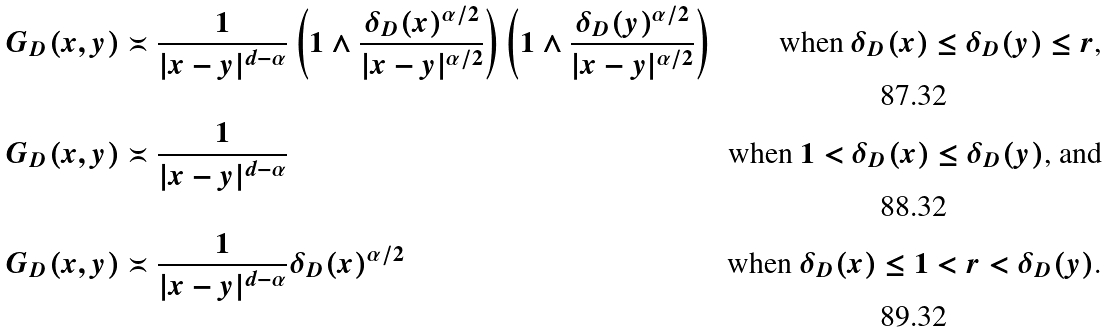<formula> <loc_0><loc_0><loc_500><loc_500>G _ { D } ( x , y ) & \asymp \frac { 1 } { | x - y | ^ { d - \alpha } } \left ( 1 \wedge \frac { \delta _ { D } ( x ) ^ { \alpha / 2 } } { | x - y | ^ { \alpha / 2 } } \right ) \left ( 1 \wedge \frac { \delta _ { D } ( y ) ^ { \alpha / 2 } } { | x - y | ^ { \alpha / 2 } } \right ) & \text {when $\delta_{D}(x) \leq \delta_{D}(y) \leq r$,} \\ G _ { D } ( x , y ) & \asymp \frac { 1 } { | x - y | ^ { d - \alpha } } & \text {when $1 < \delta_{D}(x) \leq \delta_{D}(y)$, and} \\ G _ { D } ( x , y ) & \asymp \frac { 1 } { | x - y | ^ { d - \alpha } } \delta _ { D } ( x ) ^ { \alpha / 2 } & \text {when $\delta_{D}(x) \leq 1 < r < \delta_{D}(y)$.}</formula> 